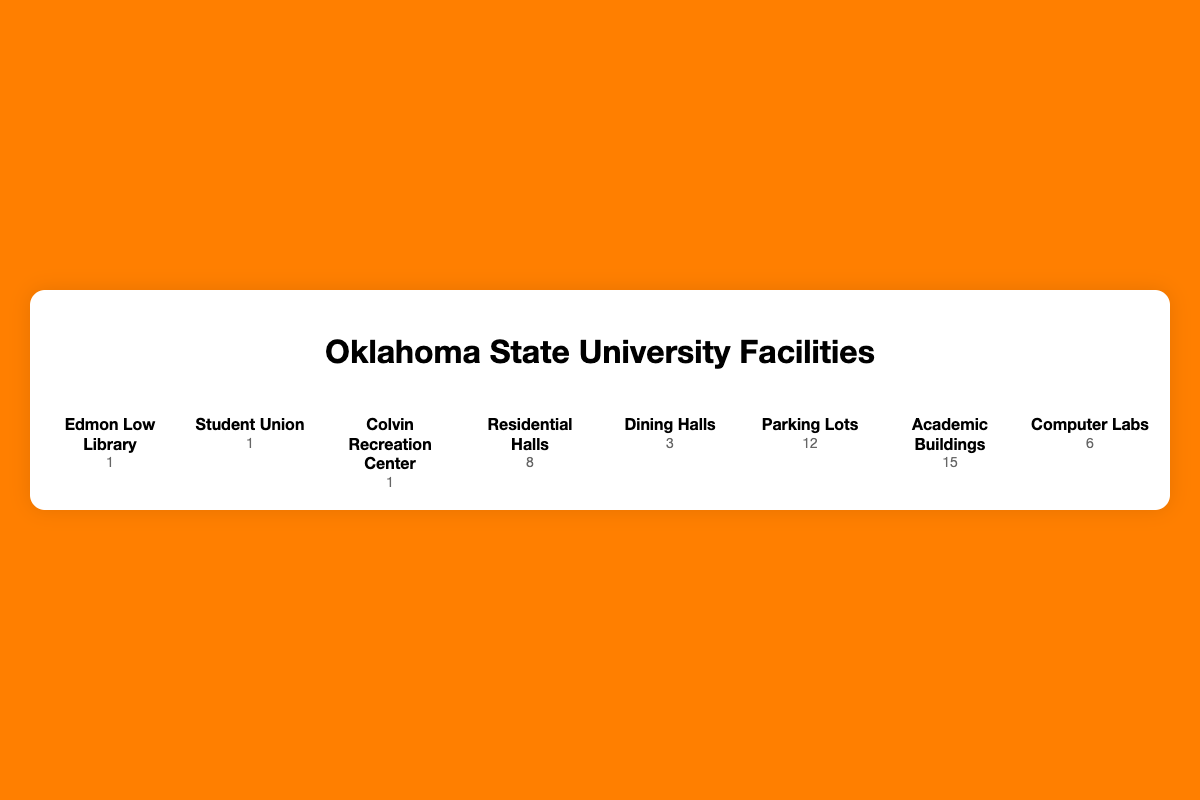What's the facility with the most icons? By looking at the number of icons associated with each facility in the plot, we see that "Academic Buildings" has the most icons, with 15 classroom icons.
Answer: Academic Buildings How many residential halls are there? The plot shows 8 bed icons under "Residential Halls," indicating the count.
Answer: 8 Which facility has the fewest icons? By quickly scanning the facilities, we see that "Edmon Low Library," "Student Union," and "Colvin Recreation Center" each have only 1 icon, the fewest among all facilities.
Answer: Edmon Low Library, Student Union, Colvin Recreation Center What's the total number of facilities represented in the plot? Counting each distinct facility listed in the plot, we find 8 unique facilities: Edmon Low Library, Student Union, Colvin Recreation Center, Residential Halls, Dining Halls, Parking Lots, Academic Buildings, and Computer Labs.
Answer: 8 How many more parking lots are there compared to computer labs? The plot shows 12 car icons for "Parking Lots" and 6 desktop icons for "Computer Labs." The difference is 12 - 6 = 6.
Answer: 6 What percentage of the facilities are dining halls? To find this, first note that there are 3 dining halls out of a total of 47 facilities (sum of all counts). The percentage is (3 / 47) * 100 ≈ 6.38%.
Answer: 6.38% Which three facilities account for the majority of the icons? To determine this, sum up the counts of each facility and check which three have the highest values: Academic Buildings (15), Parking Lots (12), and Residential Halls (8). Together, these account for 35 out of 47 total icons, the majority.
Answer: Academic Buildings, Parking Lots, Residential Halls What is the ratio of academic buildings to dining halls? The plot shows 15 academic buildings and 3 dining halls. The ratio is 15:3, which simplifies to 5:1.
Answer: 5:1 How many icons would you need to represent all facilities equally? Since the facility with the most icons has 15 (Academic Buildings), each facility would need 15 icons. So, the total would be 8 facilities * 15 icons/facility = 120 icons. Subtracting the existing 47 icons, we need 120 - 47 = 73 more icons.
Answer: 73 If you combine the number of computer labs and dining halls, would their count surpass residential halls? The plot shows 6 icons for Computer Labs and 3 for Dining Halls, making a combined total of 6 + 3 = 9. Residential Halls has 8 icons. Since 9 > 8, the combined count surpasses residential halls.
Answer: Yes 